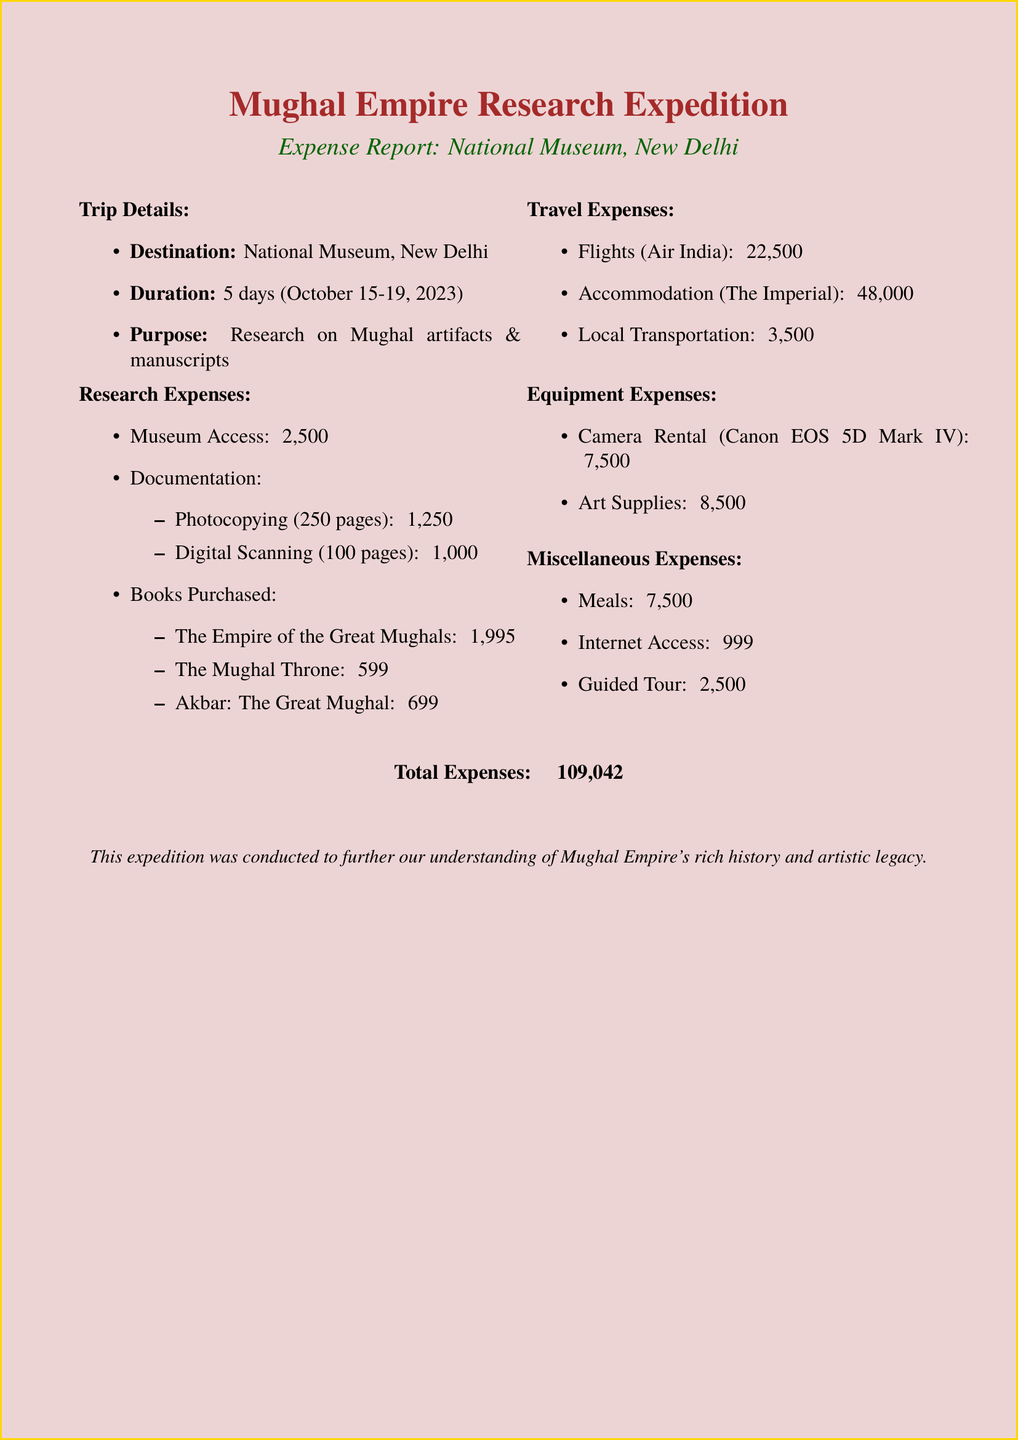What is the duration of the trip? The duration of the trip is mentioned in the document as 5 days, from October 15 to October 19, 2023.
Answer: 5 days What is the cost of the special access pass? The document states the cost for the special access pass is ₹2000.
Answer: ₹2000 How many pages were photocopied? The document specifies that 250 pages were photocopied.
Answer: 250 pages Who is the author of "Akbar: The Great Mughal"? The author's name is listed in the document as Ira Mukhoty.
Answer: Ira Mukhoty What is the total accommodation cost? The total accommodation cost is calculated as the nightly rate (₹12,000) multiplied by the number of nights (4), resulting in ₹48,000.
Answer: ₹48,000 What guided tour was taken during the trip? The document mentions the guided tour as "Mughal Delhi Heritage Walk."
Answer: Mughal Delhi Heritage Walk What was the total number of research expenses? The total of research expenses is calculated by summing all expenses listed under research, resulting in ₹7,500.
Answer: ₹7,500 Which camera model was rented? The document specifies the rental camera model as "Canon EOS 5D Mark IV."
Answer: Canon EOS 5D Mark IV What is the average daily cost for meals? The average daily cost for meals is stated in the document as ₹1,500.
Answer: ₹1,500 